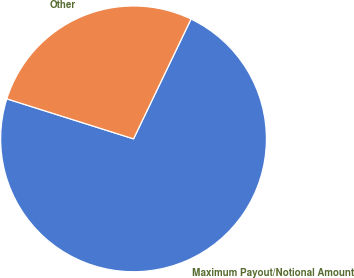<chart> <loc_0><loc_0><loc_500><loc_500><pie_chart><fcel>Maximum Payout/Notional Amount<fcel>Other<nl><fcel>72.75%<fcel>27.25%<nl></chart> 